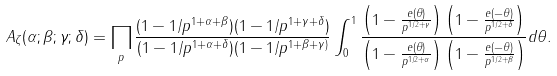<formula> <loc_0><loc_0><loc_500><loc_500>A _ { \zeta } ( \alpha ; \beta ; \gamma ; \delta ) = \prod _ { p } \frac { ( 1 - 1 / p ^ { 1 + \alpha + \beta } ) ( 1 - 1 / p ^ { 1 + \gamma + \delta } ) } { ( 1 - 1 / p ^ { 1 + \alpha + \delta } ) ( 1 - 1 / p ^ { 1 + \beta + \gamma ) } } \int _ { 0 } ^ { 1 } \frac { \left ( 1 - \frac { e ( \theta ) } { p ^ { 1 / 2 + \gamma } } \right ) \left ( 1 - \frac { e ( - \theta ) } { p ^ { 1 / 2 + \delta } } \right ) } { \left ( 1 - \frac { e ( \theta ) } { p ^ { 1 / 2 + \alpha } } \right ) \left ( 1 - \frac { e ( - \theta ) } { p ^ { 1 / 2 + \beta } } \right ) } d \theta .</formula> 